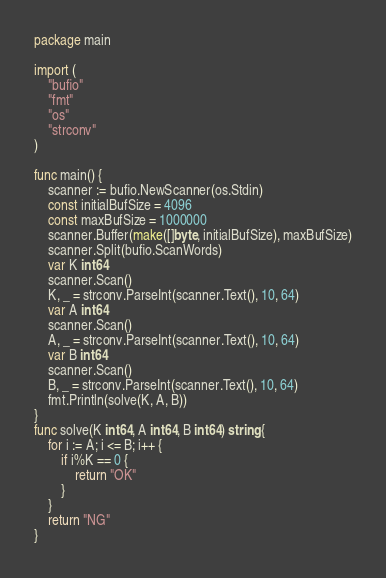<code> <loc_0><loc_0><loc_500><loc_500><_Go_>package main

import (
	"bufio"
	"fmt"
	"os"
	"strconv"
)

func main() {
	scanner := bufio.NewScanner(os.Stdin)
	const initialBufSize = 4096
	const maxBufSize = 1000000
	scanner.Buffer(make([]byte, initialBufSize), maxBufSize)
	scanner.Split(bufio.ScanWords)
	var K int64
	scanner.Scan()
	K, _ = strconv.ParseInt(scanner.Text(), 10, 64)
	var A int64
	scanner.Scan()
	A, _ = strconv.ParseInt(scanner.Text(), 10, 64)
	var B int64
	scanner.Scan()
	B, _ = strconv.ParseInt(scanner.Text(), 10, 64)
	fmt.Println(solve(K, A, B))
}
func solve(K int64, A int64, B int64) string {
	for i := A; i <= B; i++ {
		if i%K == 0 {
			return "OK"
		}
	}
	return "NG"
}
</code> 